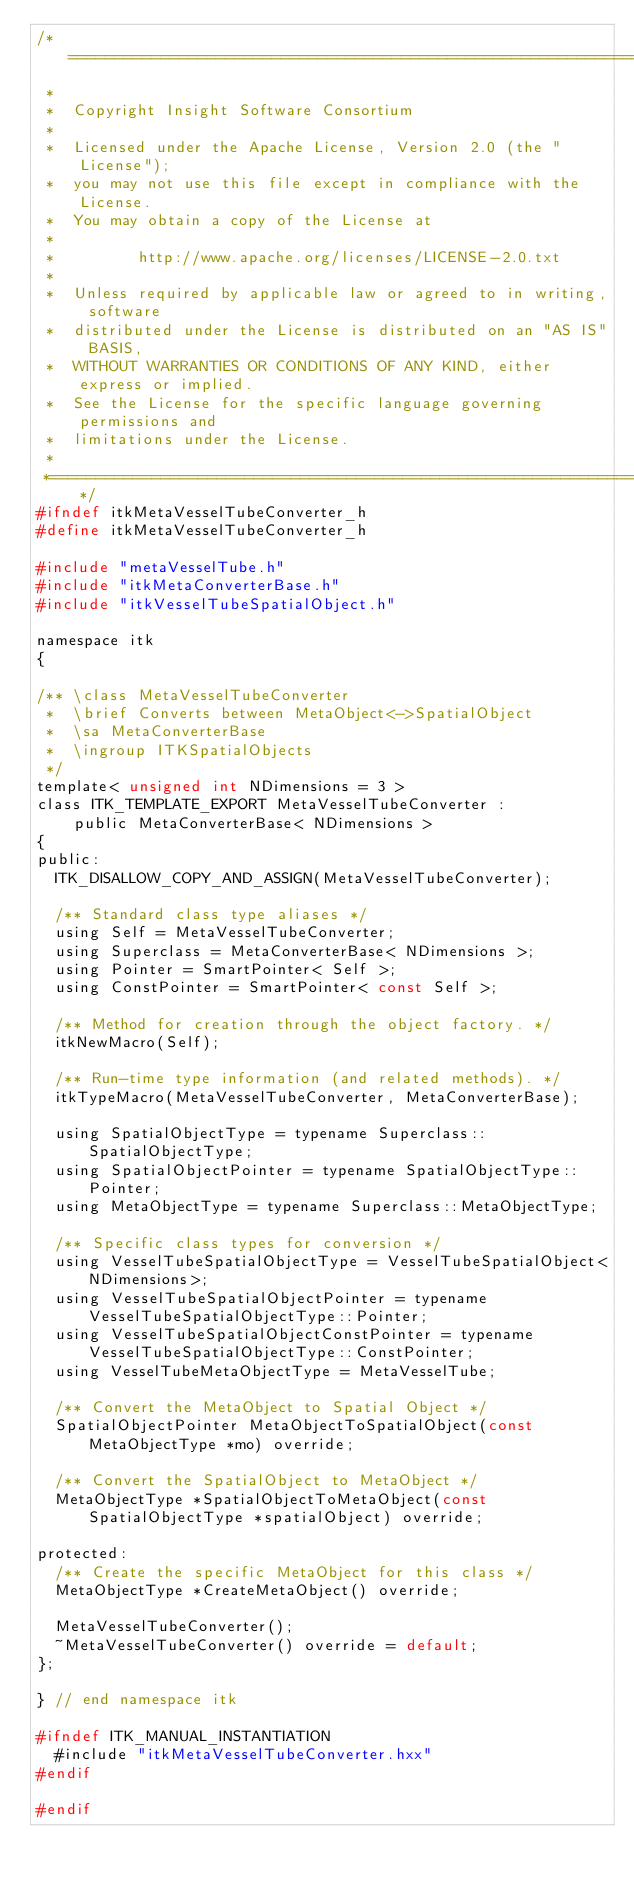<code> <loc_0><loc_0><loc_500><loc_500><_C_>/*=========================================================================
 *
 *  Copyright Insight Software Consortium
 *
 *  Licensed under the Apache License, Version 2.0 (the "License");
 *  you may not use this file except in compliance with the License.
 *  You may obtain a copy of the License at
 *
 *         http://www.apache.org/licenses/LICENSE-2.0.txt
 *
 *  Unless required by applicable law or agreed to in writing, software
 *  distributed under the License is distributed on an "AS IS" BASIS,
 *  WITHOUT WARRANTIES OR CONDITIONS OF ANY KIND, either express or implied.
 *  See the License for the specific language governing permissions and
 *  limitations under the License.
 *
 *=========================================================================*/
#ifndef itkMetaVesselTubeConverter_h
#define itkMetaVesselTubeConverter_h

#include "metaVesselTube.h"
#include "itkMetaConverterBase.h"
#include "itkVesselTubeSpatialObject.h"

namespace itk
{

/** \class MetaVesselTubeConverter
 *  \brief Converts between MetaObject<->SpatialObject
 *  \sa MetaConverterBase
 *  \ingroup ITKSpatialObjects
 */
template< unsigned int NDimensions = 3 >
class ITK_TEMPLATE_EXPORT MetaVesselTubeConverter :
    public MetaConverterBase< NDimensions >
{
public:
  ITK_DISALLOW_COPY_AND_ASSIGN(MetaVesselTubeConverter);

  /** Standard class type aliases */
  using Self = MetaVesselTubeConverter;
  using Superclass = MetaConverterBase< NDimensions >;
  using Pointer = SmartPointer< Self >;
  using ConstPointer = SmartPointer< const Self >;

  /** Method for creation through the object factory. */
  itkNewMacro(Self);

  /** Run-time type information (and related methods). */
  itkTypeMacro(MetaVesselTubeConverter, MetaConverterBase);

  using SpatialObjectType = typename Superclass::SpatialObjectType;
  using SpatialObjectPointer = typename SpatialObjectType::Pointer;
  using MetaObjectType = typename Superclass::MetaObjectType;

  /** Specific class types for conversion */
  using VesselTubeSpatialObjectType = VesselTubeSpatialObject<NDimensions>;
  using VesselTubeSpatialObjectPointer = typename VesselTubeSpatialObjectType::Pointer;
  using VesselTubeSpatialObjectConstPointer = typename VesselTubeSpatialObjectType::ConstPointer;
  using VesselTubeMetaObjectType = MetaVesselTube;

  /** Convert the MetaObject to Spatial Object */
  SpatialObjectPointer MetaObjectToSpatialObject(const MetaObjectType *mo) override;

  /** Convert the SpatialObject to MetaObject */
  MetaObjectType *SpatialObjectToMetaObject(const SpatialObjectType *spatialObject) override;

protected:
  /** Create the specific MetaObject for this class */
  MetaObjectType *CreateMetaObject() override;

  MetaVesselTubeConverter();
  ~MetaVesselTubeConverter() override = default;
};

} // end namespace itk

#ifndef ITK_MANUAL_INSTANTIATION
  #include "itkMetaVesselTubeConverter.hxx"
#endif

#endif
</code> 